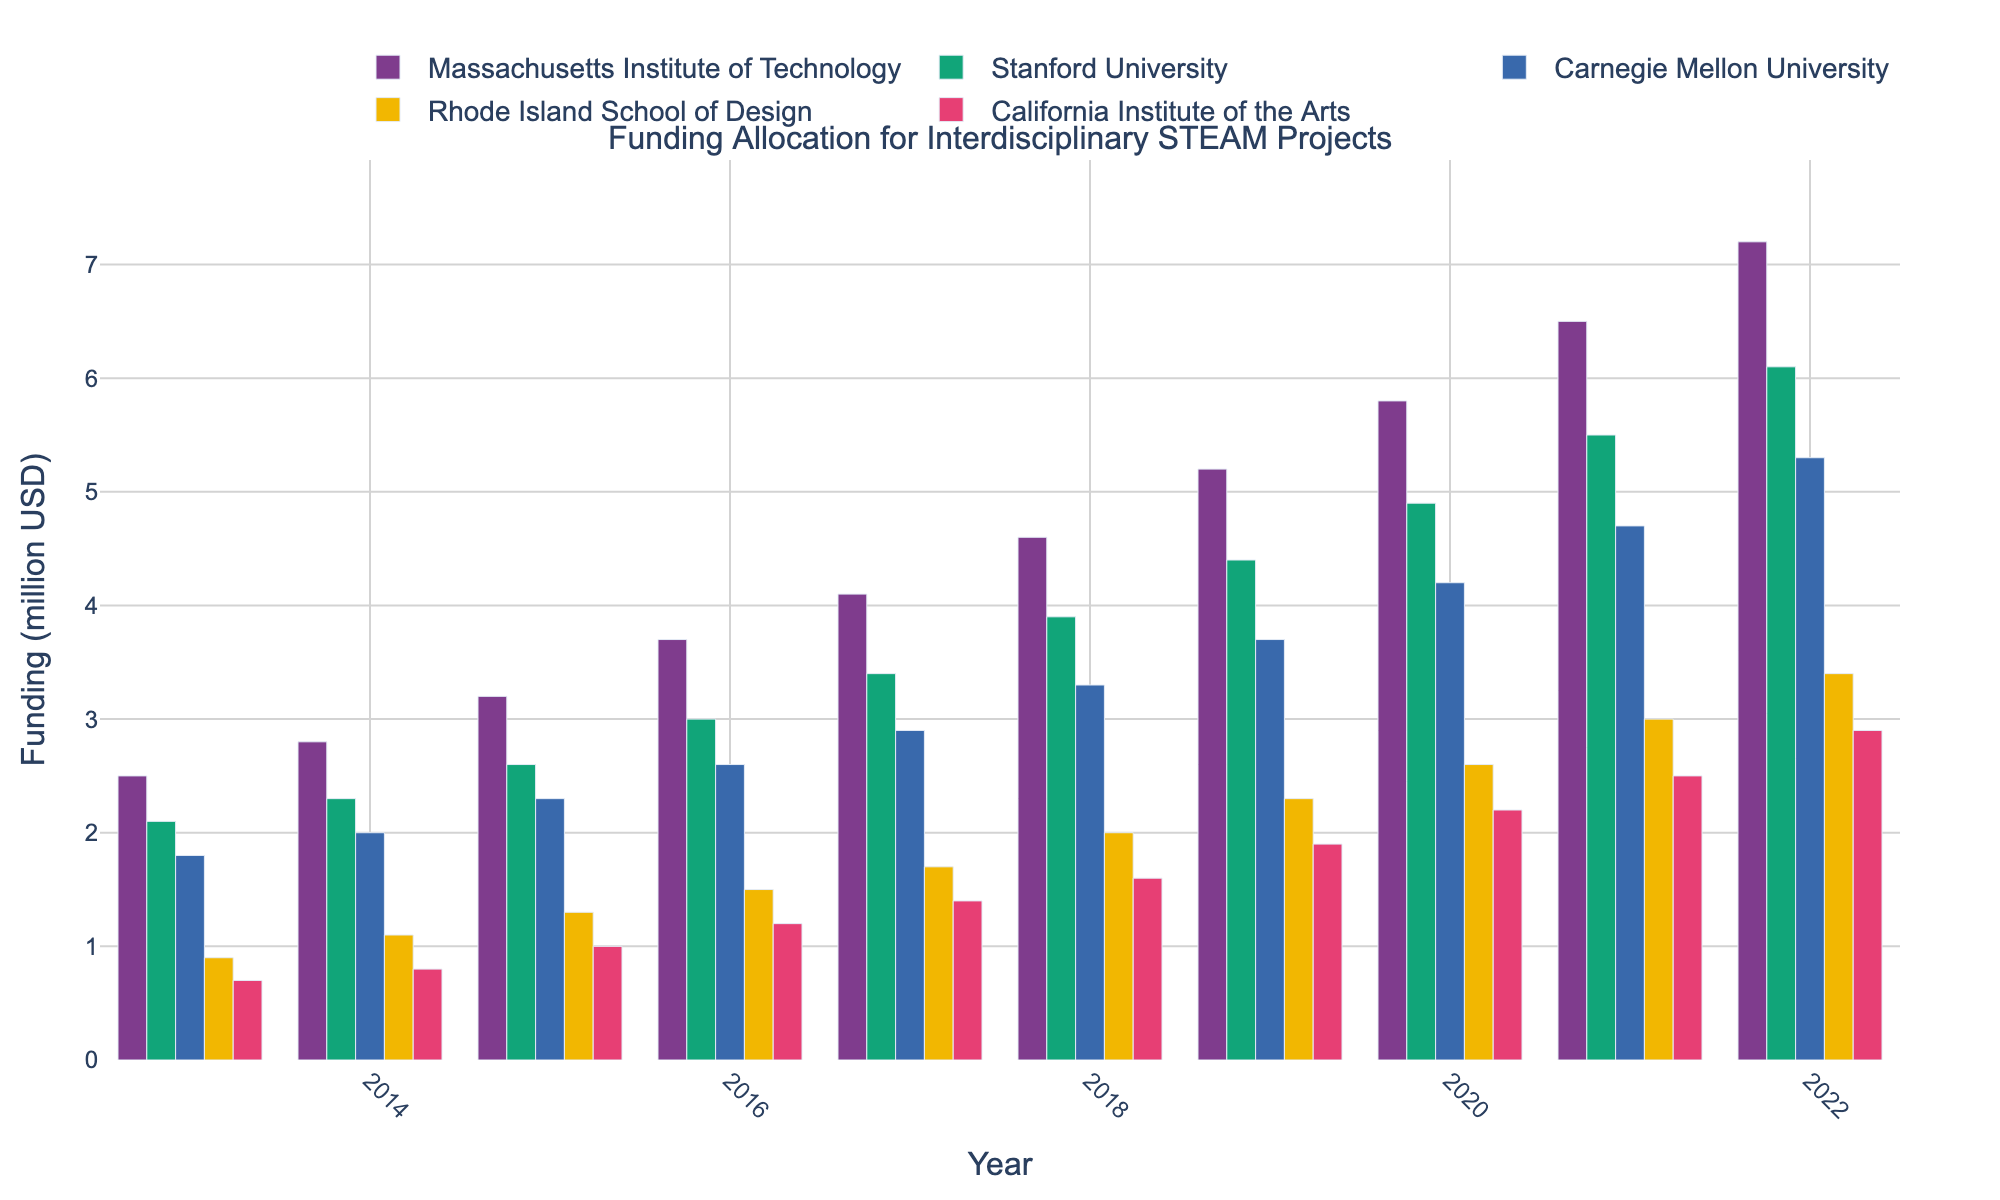What is the trend for funding allocation at Massachusetts Institute of Technology over the past decade? Observing the height of the bars corresponding to Massachusetts Institute of Technology, we see a consistent upward trend from 2013 to 2022, indicating a steady increase in funding allocation each year.
Answer: Upward trend In which year did Stanford University receive the highest funding? By comparing the bar heights for Stanford University over the different years, it’s clear that 2022 has the highest bar, indicating the highest funding.
Answer: 2022 Which institution had the least funding in 2018? By comparing the heights of all bars in 2018, the bar for California Institute of the Arts is the shortest, indicating it had the least funding.
Answer: California Institute of the Arts How much did the funding for Carnegie Mellon University increase from 2013 to 2019? In 2013, Carnegie Mellon University had 1.8 million USD, and in 2019, it had 3.7 million USD. The increase is 3.7 - 1.8 million USD = 1.9 million USD.
Answer: 1.9 million USD Between Rhode Island School of Design and California Institute of the Arts, which institution saw a larger increase in funding from 2016 to 2022? Rhode Island School of Design had an increase from 1.5 million USD in 2016 to 3.4 million USD in 2022, a change of 3.4 - 1.5 = 1.9 million USD. California Institute of the Arts had an increase from 1.2 million USD in 2016 to 2.9 million USD in 2022, a change of 2.9 - 1.2 = 1.7 million USD. Therefore, Rhode Island School of Design saw a larger increase.
Answer: Rhode Island School of Design By how much did funding for Massachusetts Institute of Technology exceed that of California Institute of the Arts in 2022? In 2022, Massachusetts Institute of Technology received 7.2 million USD and California Institute of the Arts received 2.9 million USD. The difference is 7.2 - 2.9 million USD = 4.3 million USD.
Answer: 4.3 million USD What is the average funding for Stanford University over the decade? Adding the funding amounts for Stanford University from 2013 to 2022: 2.1 + 2.3 + 2.6 + 3.0 + 3.4 + 3.9 + 4.4 + 4.9 + 5.5 + 6.1 = 38.2. Dividing by the number of years (10), the average funding is 38.2 / 10 = 3.82 million USD.
Answer: 3.82 million USD Which institution had the higher peak funding, Massachusetts Institute of Technology or Stanford University? Comparing the highest bars of both institutions, Massachusetts Institute of Technology peaked at 7.2 million USD in 2022, and Stanford University peaked at 6.1 million USD in the same year. Therefore, Massachusetts Institute of Technology had the higher peak funding.
Answer: Massachusetts Institute of Technology 